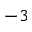Convert formula to latex. <formula><loc_0><loc_0><loc_500><loc_500>^ { - 3 }</formula> 